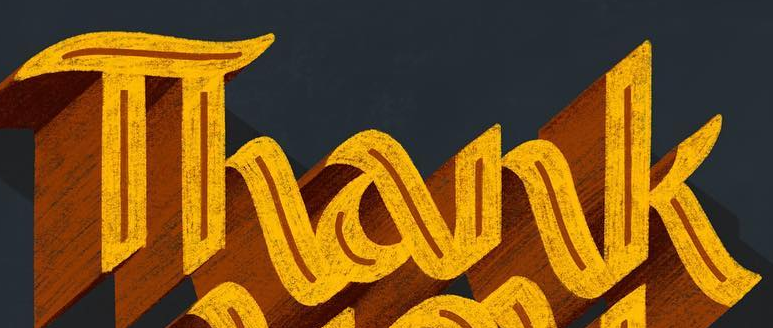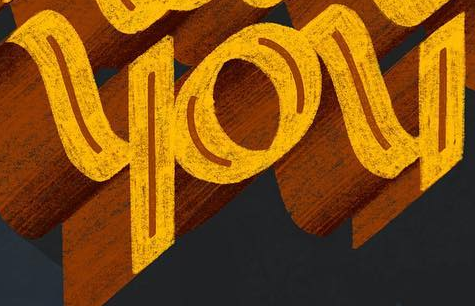Read the text from these images in sequence, separated by a semicolon. Thank; you 